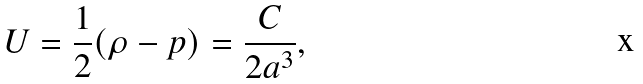Convert formula to latex. <formula><loc_0><loc_0><loc_500><loc_500>U = \frac { 1 } { 2 } ( \rho - p ) = \frac { C } { 2 a ^ { 3 } } ,</formula> 